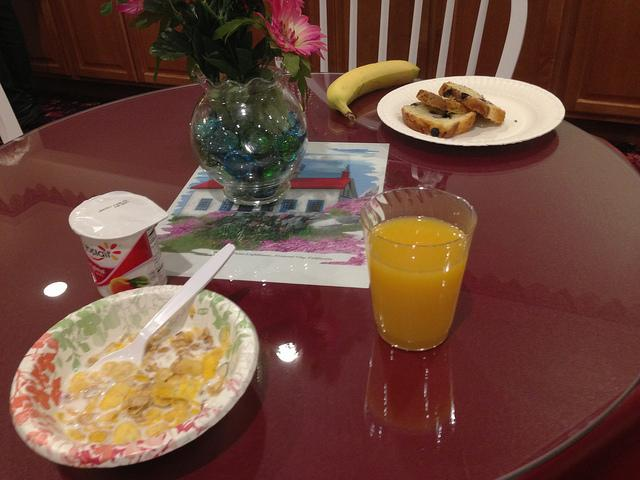What fruit used to prepare items here is darkest?

Choices:
A) apricots
B) bananas
C) oranges
D) blueberries blueberries 